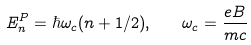Convert formula to latex. <formula><loc_0><loc_0><loc_500><loc_500>E _ { n } ^ { P } = \hbar { \omega } _ { c } ( n + 1 / 2 ) , \quad \omega _ { c } = \frac { e B } { m c }</formula> 